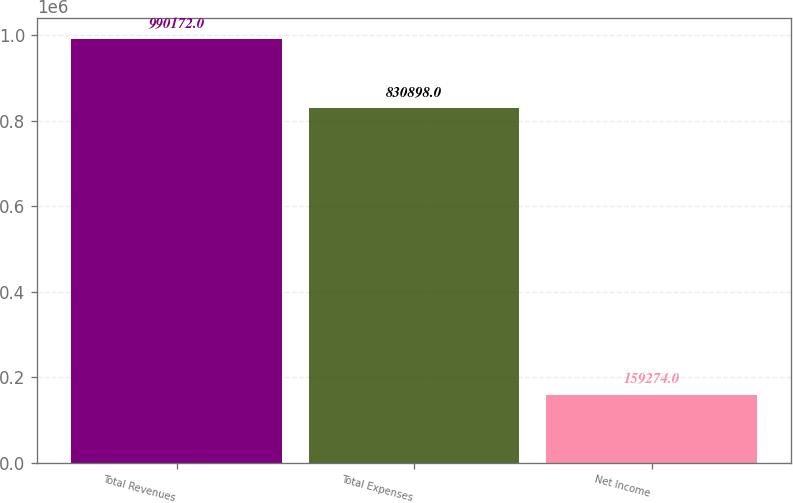Convert chart. <chart><loc_0><loc_0><loc_500><loc_500><bar_chart><fcel>Total Revenues<fcel>Total Expenses<fcel>Net Income<nl><fcel>990172<fcel>830898<fcel>159274<nl></chart> 